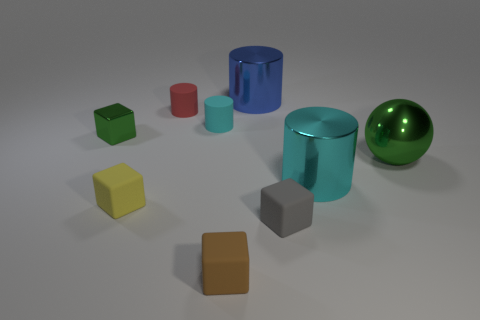Do the big cylinder that is in front of the cyan rubber cylinder and the tiny cylinder in front of the red object have the same color?
Your answer should be very brief. Yes. There is a green metal object on the right side of the small yellow rubber block; how many big metallic cylinders are in front of it?
Offer a very short reply. 1. There is a red thing that is the same size as the brown matte block; what is its material?
Give a very brief answer. Rubber. What number of other things are the same material as the green block?
Make the answer very short. 3. How many objects are on the right side of the shiny cube?
Provide a short and direct response. 8. How many balls are either large cyan objects or tiny red things?
Keep it short and to the point. 0. What is the size of the cube that is both to the right of the cyan matte object and behind the brown matte cube?
Your response must be concise. Small. What number of other things are the same color as the tiny metallic block?
Your response must be concise. 1. Is the material of the blue thing the same as the small yellow thing that is on the left side of the red cylinder?
Provide a short and direct response. No. How many things are small matte things that are in front of the big green metallic thing or small matte things?
Provide a succinct answer. 5. 